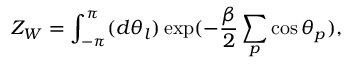Convert formula to latex. <formula><loc_0><loc_0><loc_500><loc_500>Z _ { W } = \int _ { - \pi } ^ { \pi } ( d \theta _ { l } ) \exp ( - \frac { \beta } { 2 } \sum _ { p } \cos { \theta } _ { p } ) ,</formula> 